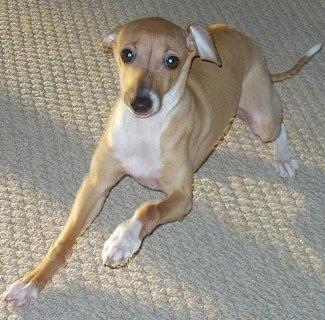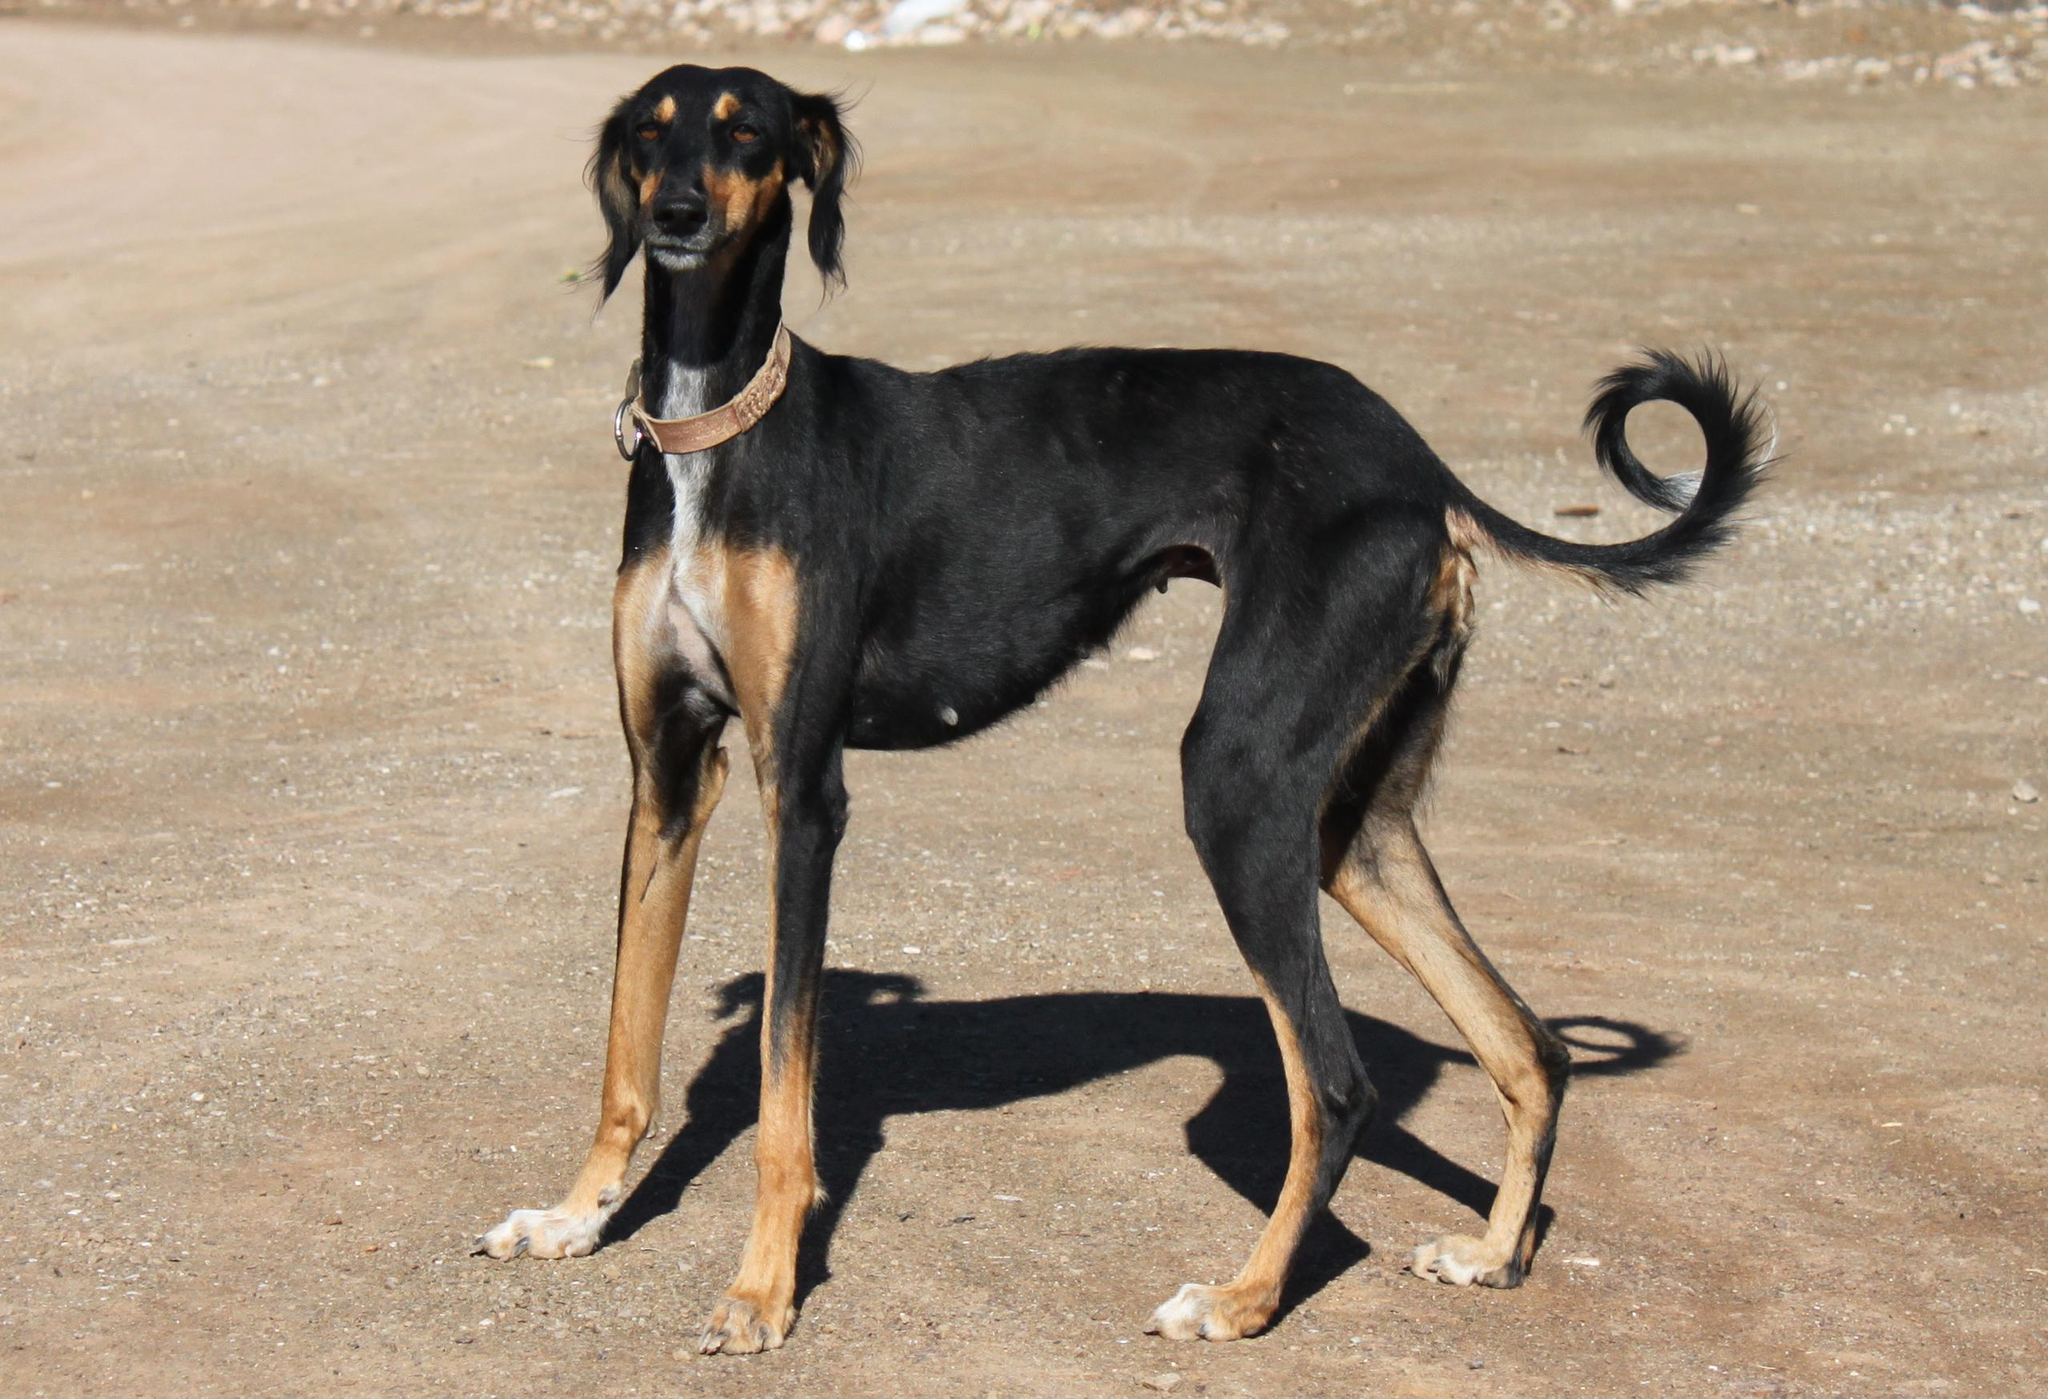The first image is the image on the left, the second image is the image on the right. Assess this claim about the two images: "One of the images contains a dog without visible legs.". Correct or not? Answer yes or no. No. 